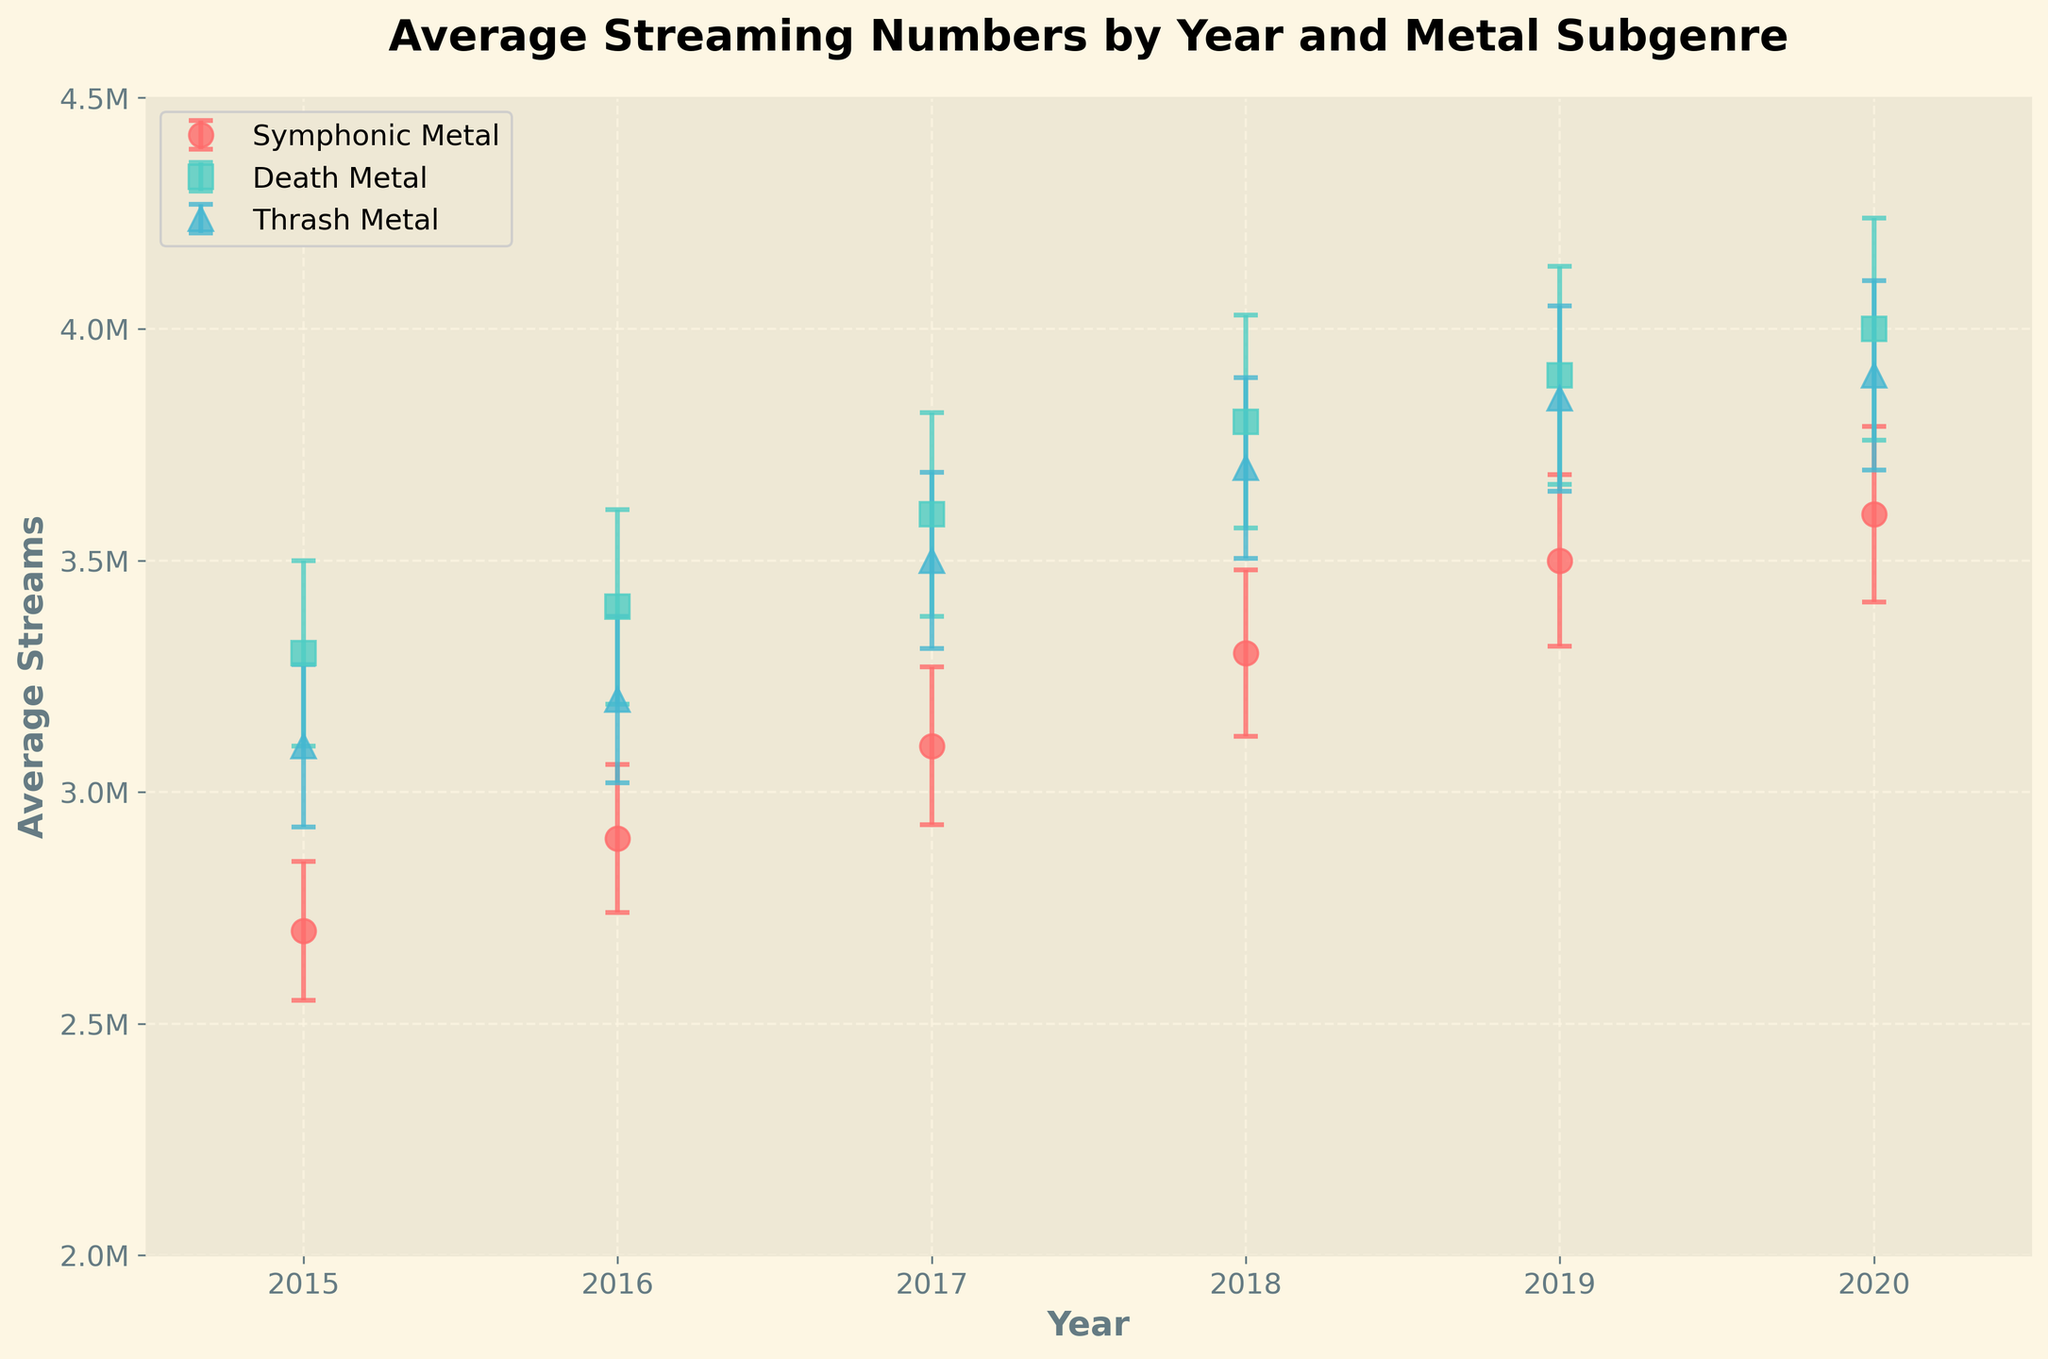What's the title of the plot? The title is located at the top of the plot and describes what the plot represents.
Answer: Average Streaming Numbers by Year and Metal Subgenre What is the average streaming number for Symphonic Metal in 2019? Look for the point corresponding to Symphonic Metal in 2019 on the plot and read the average streaming number value.
Answer: 3,500,000 How does the streaming number of Thrash Metal in 2020 compare to that in 2019? Compare the y-values of the Thrash Metal data points for the years 2019 and 2020. The point in 2020 is slightly higher than in 2019.
Answer: It increased Which genre had the lowest average streams in 2015? Compare the y-values of the points for 2015 and determine the genre with the lowest value. Symphonic Metal is the lowest at 2,700,000.
Answer: Symphonic Metal How much is the error margin for Death Metal in 2020 compared to Thrash Metal in the same year? Identify the error bars for both Death Metal and Thrash Metal in 2020. Subtract the error bar value of Thrash Metal from Death Metal.
Answer: 35,000 What has been the trend for Symphonic Metal streaming numbers from 2015 to 2020? Look at the sequence of points for Symphonic Metal across the years. Ensure to observe how the average streaming numbers change over time.
Answer: Increasing Which year shows the largest increase in average streams for Death Metal compared to the previous year? Calculate the differences in average streams for Death Metal between consecutive years and identify the largest. The difference between 2016 and 2017 is the largest.
Answer: 2017 In which year did Thrash Metal have the smallest error margin? Look at the error bars for Thrash Metal across all the years and identify the smallest one.
Answer: 2015 What's the total average streaming number for all genres in 2018? Sum the average streams for Symphonic Metal, Death Metal, and Thrash Metal in 2018. 3,300,000 + 3,800,000 + 3,700,000 = 10,800,000
Answer: 10,800,000 How do the average streaming numbers for 2015 compare among the three subgenres? Compare the y-values of the points for 2015 for Symphonic Metal, Death Metal, and Thrash Metal. Identify which genre has the highest and which one has the lowest.
Answer: Death Metal has the highest, Symphonic Metal has the lowest 